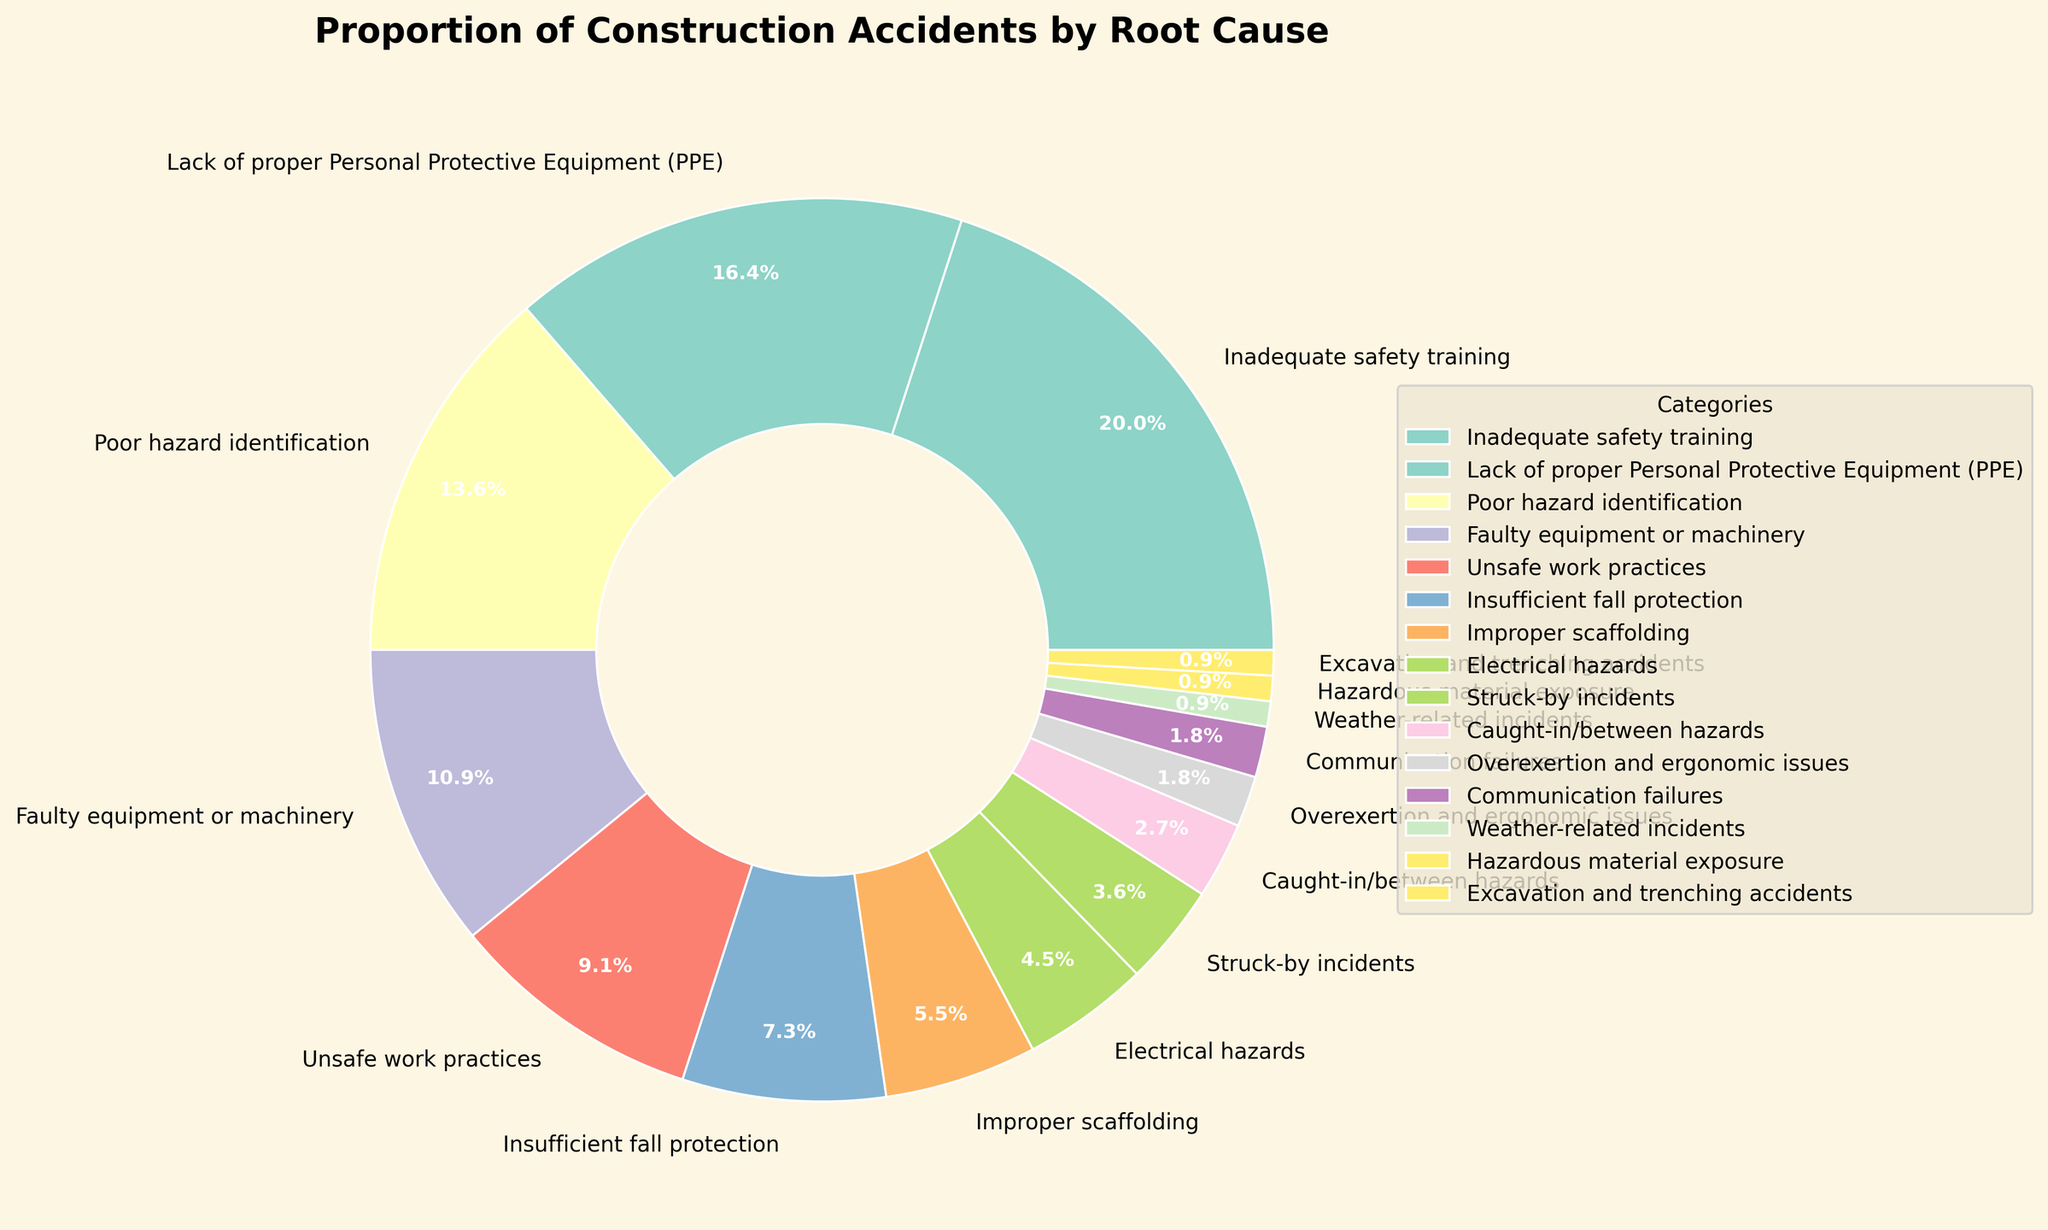What's the largest root cause of construction accidents, according to the pie chart? The biggest section of the pie chart, represented by the highest percentage, indicates the largest root cause. In this chart, "Inadequate safety training" occupies the largest segment at 22%.
Answer: "Inadequate safety training" Which root cause of construction accidents is represented by 18% in the pie chart? We look for the segment that occupies 18% of the pie. The label next to this segment is "Lack of proper Personal Protective Equipment (PPE)".
Answer: "Lack of proper Personal Protective Equipment (PPE)" What proportion of construction accidents can be attributed to improper scaffolding and electrical hazards combined? To find the combined proportion, sum the percentages for "Improper scaffolding" (6%) and "Electrical hazards" (5%). The total is 6% + 5% = 11%.
Answer: 11% Between poor hazard identification and faulty equipment or machinery, which root cause is more frequent, and by how much? Poor hazard identification is 15%, and faulty equipment or machinery is 12%. The difference is 15% - 12% = 3%. Poor hazard identification is more frequent by 3%.
Answer: Poor hazard identification by 3% How much larger is the proportion of accidents caused by unsafe work practices compared to electrical hazards? Unsafe work practices are 10%, and electrical hazards are 5%. The difference is 10% - 5% = 5%.
Answer: 5% What is the combined percentage of construction accidents for the three smallest root cause categories? The smallest three categories are "Hazardous material exposure" (1%), "Weather-related incidents" (1%), and "Excavation and trenching accidents" (1%). The total combined percentage is 1% + 1% + 1% = 3%.
Answer: 3% How does the proportion of accidents due to inadequate safety training compare to accidents due to insufficient fall protection? Inadequate safety training accounts for 22% while insufficient fall protection is 8%. The difference is 22% - 8% = 14%. Inadequate safety training is 14% more.
Answer: 14% more Which categories have percentages that sum up to at least 25% when combined? Combining the top two categories: "Inadequate safety training" (22%) and "Lack of proper Personal Protective Equipment (PPE)" (18%) sums to 22% + 18% = 40% which is greater than 25%. Any larger combination will also meet this threshold.
Answer: Inadequate safety training and Lack of proper PPE How does the proportion of accidents due to overexertion and ergonomic issues compare to those caused by communication failures? Both categories have the same percentage, each accounting for 2% of the accidents.
Answer: Equal What is the next largest cause of construction accidents after inadequate safety training and lack of proper PPE? After examining the chart, the next largest cause after inadequate safety training (22%) and lack of proper PPE (18%) is poor hazard identification at 15%.
Answer: Poor hazard identification 